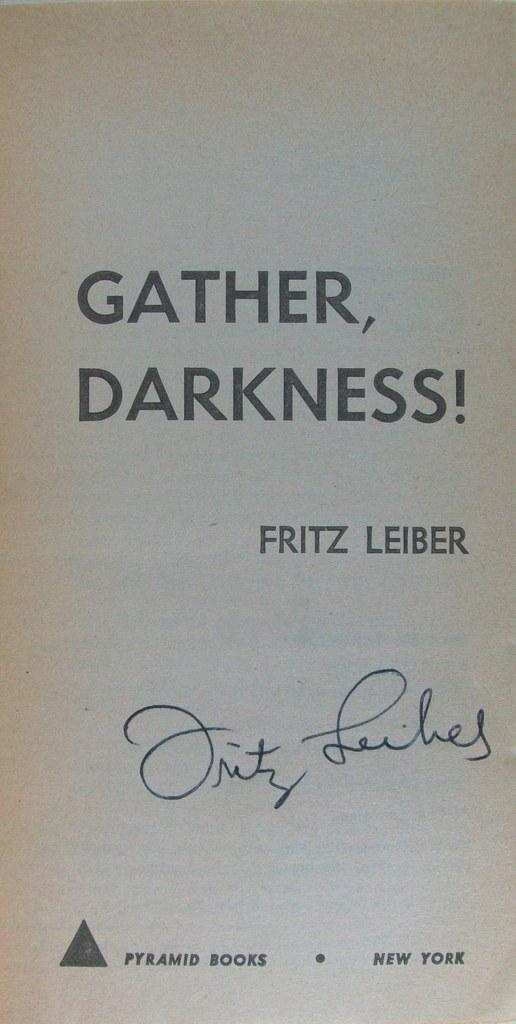Who is the author?
Make the answer very short. Fritz leiber. Who is the publisher of this book>?
Your answer should be very brief. Pyramid books. 